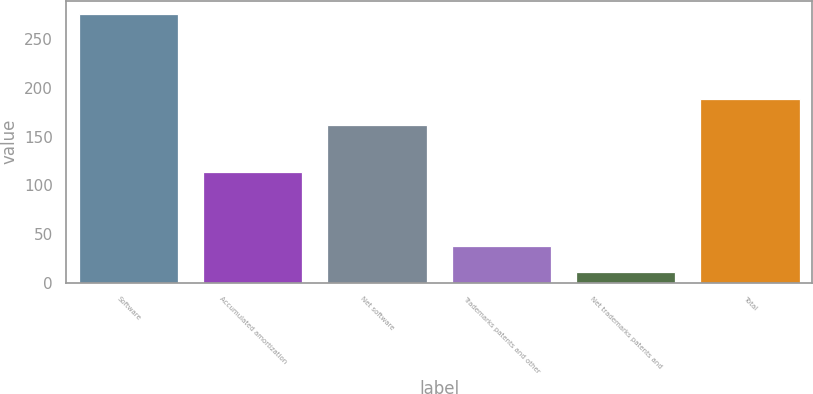Convert chart. <chart><loc_0><loc_0><loc_500><loc_500><bar_chart><fcel>Software<fcel>Accumulated amortization<fcel>Net software<fcel>Trademarks patents and other<fcel>Net trademarks patents and<fcel>Total<nl><fcel>276<fcel>114<fcel>162<fcel>37.5<fcel>11<fcel>188.5<nl></chart> 